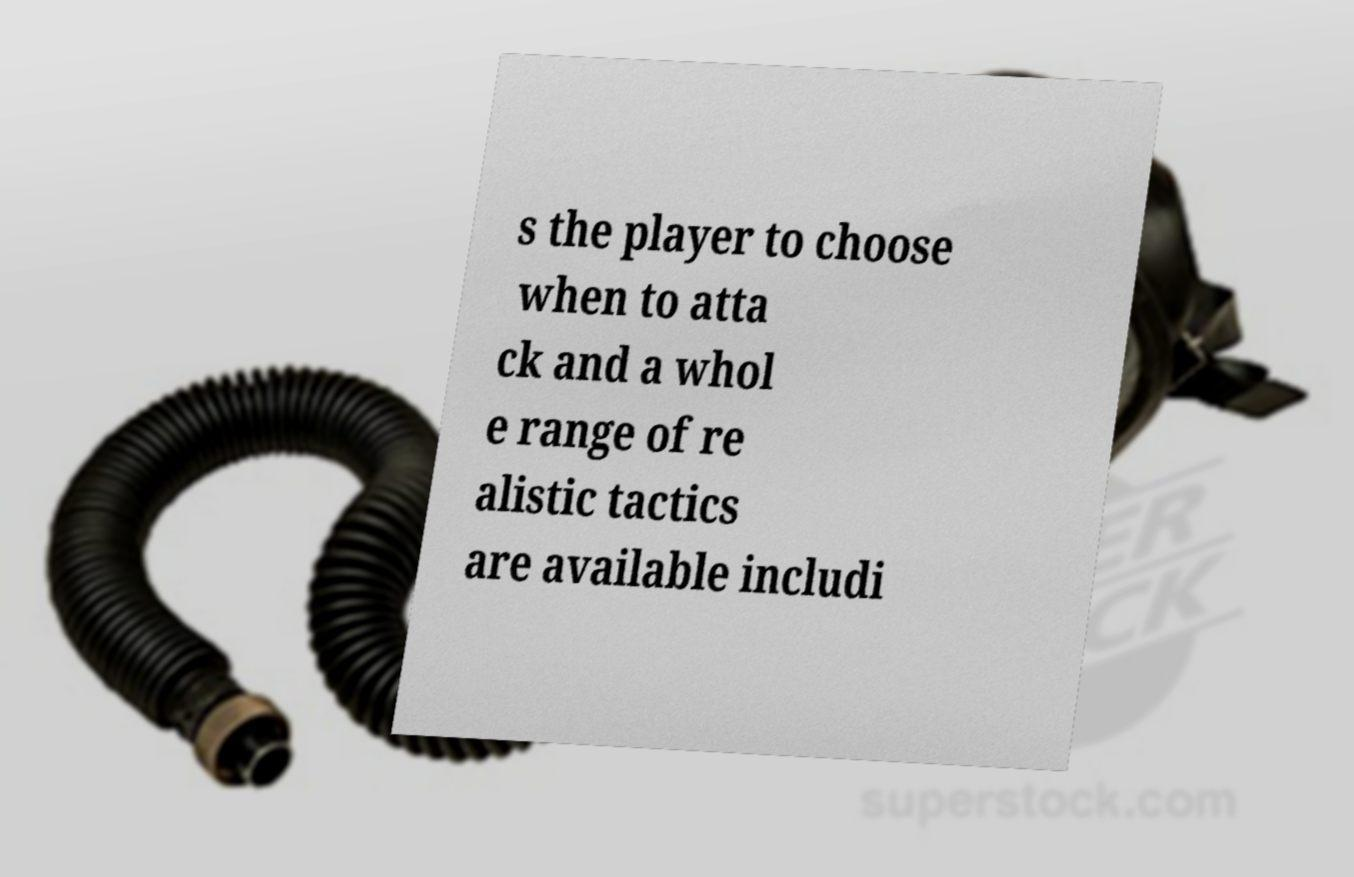I need the written content from this picture converted into text. Can you do that? s the player to choose when to atta ck and a whol e range of re alistic tactics are available includi 